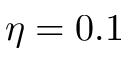<formula> <loc_0><loc_0><loc_500><loc_500>\eta = 0 . 1</formula> 